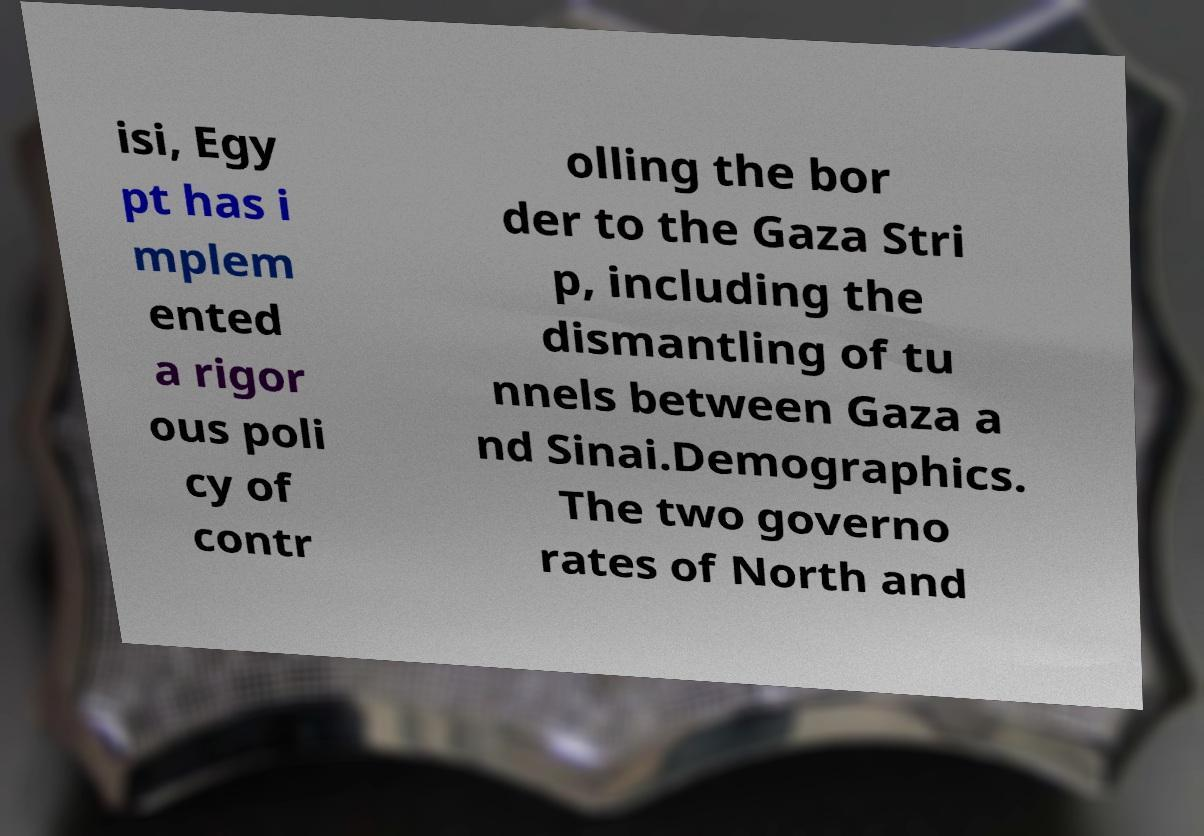Could you assist in decoding the text presented in this image and type it out clearly? isi, Egy pt has i mplem ented a rigor ous poli cy of contr olling the bor der to the Gaza Stri p, including the dismantling of tu nnels between Gaza a nd Sinai.Demographics. The two governo rates of North and 